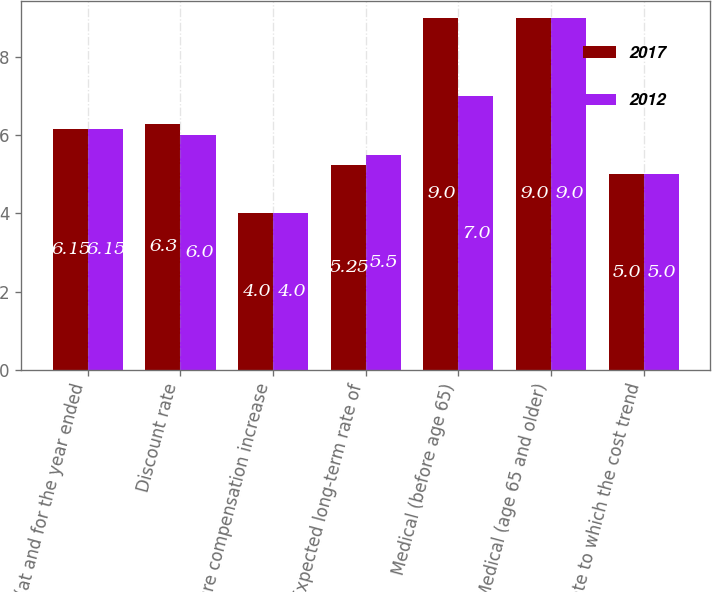Convert chart. <chart><loc_0><loc_0><loc_500><loc_500><stacked_bar_chart><ecel><fcel>(at and for the year ended<fcel>Discount rate<fcel>Future compensation increase<fcel>Expected long-term rate of<fcel>Medical (before age 65)<fcel>Medical (age 65 and older)<fcel>Rate to which the cost trend<nl><fcel>2017<fcel>6.15<fcel>6.3<fcel>4<fcel>5.25<fcel>9<fcel>9<fcel>5<nl><fcel>2012<fcel>6.15<fcel>6<fcel>4<fcel>5.5<fcel>7<fcel>9<fcel>5<nl></chart> 